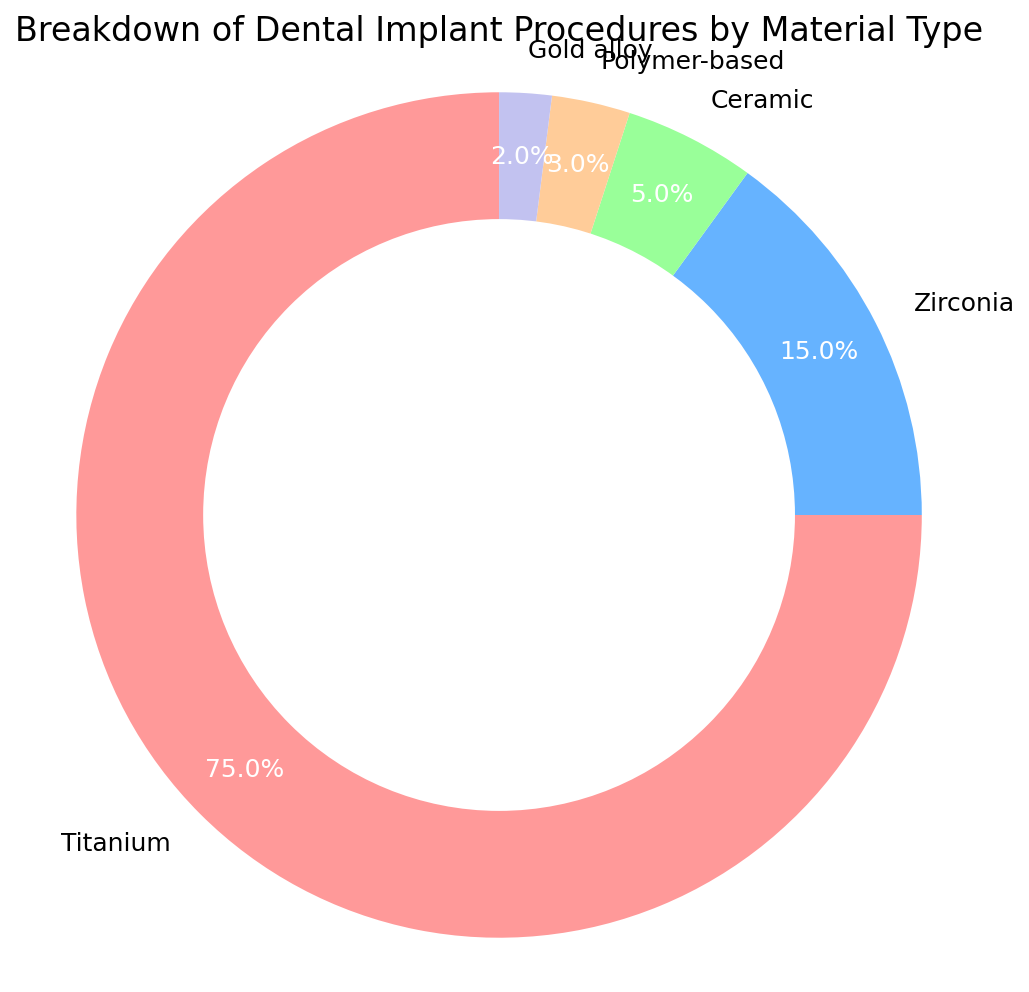Which material is most commonly used for dental implants? The pie chart shows that Titanium occupies the largest section, clearly indicating it is the most commonly used material.
Answer: Titanium What percentage of dental implants are made from zirconia? According to the pie chart, the section representing Zirconia is labeled with its percentage.
Answer: 15% How does the percentage of ceramic implants compare to that of polymer-based implants? The pie chart shows Ceramic at 5% and Polymer-based at 3%. Comparing these numbers, Ceramic is greater than Polymer-based.
Answer: Ceramic is greater than Polymer-based What percentage of dental implant procedures are made from materials other than titanium? The pie chart shows the percentage for Titanium. Subtracting this from 100% will give the percentage for other materials. The calculation is 100% - 75% = 25%.
Answer: 25% Which material type makes up the smallest portion of dental implants? By looking at the pie chart, the smallest section is labeled as Gold alloy with only 2%.
Answer: Gold alloy If you combine the percentages of the two least common materials, what would be their total percentage? The pie chart shows Gold alloy at 2% and Polymer-based at 3%. Adding these together gives 2% + 3% = 5%.
Answer: 5% What is the combined percentage of ceramic and zirconia implants? The pie chart shows Ceramic at 5% and Zirconia at 15%. Adding these together gives 5% + 15% = 20%.
Answer: 20% How many times larger is the percentage of titanium implants compared to gold alloy implants? The pie chart shows Titanium at 75% and Gold alloy at 2%. Dividing these percentages gives 75% / 2% = 37.5.
Answer: 37.5 times What color represents polymer-based implants on the chart? By visually inspecting the pie chart, polymer-based implants are represented by a beige-like color.
Answer: Beige Between zirconia and ceramic, which material is more commonly used, and by what percentage difference? Zirconia is at 15% and Ceramic is at 5%. Subtracting these gives 15% - 5% = 10%.
Answer: Zirconia by 10% If you were to remove titanium implants from the dataset, what percentage would zirconia now represent out of the remaining materials? The remaining materials add up to 25% (100% - 75%). Given Zirconia is 15%, out of the remaining 25%, the new percentage for Zirconia would be (15/25) * 100% = 60%.
Answer: 60% 